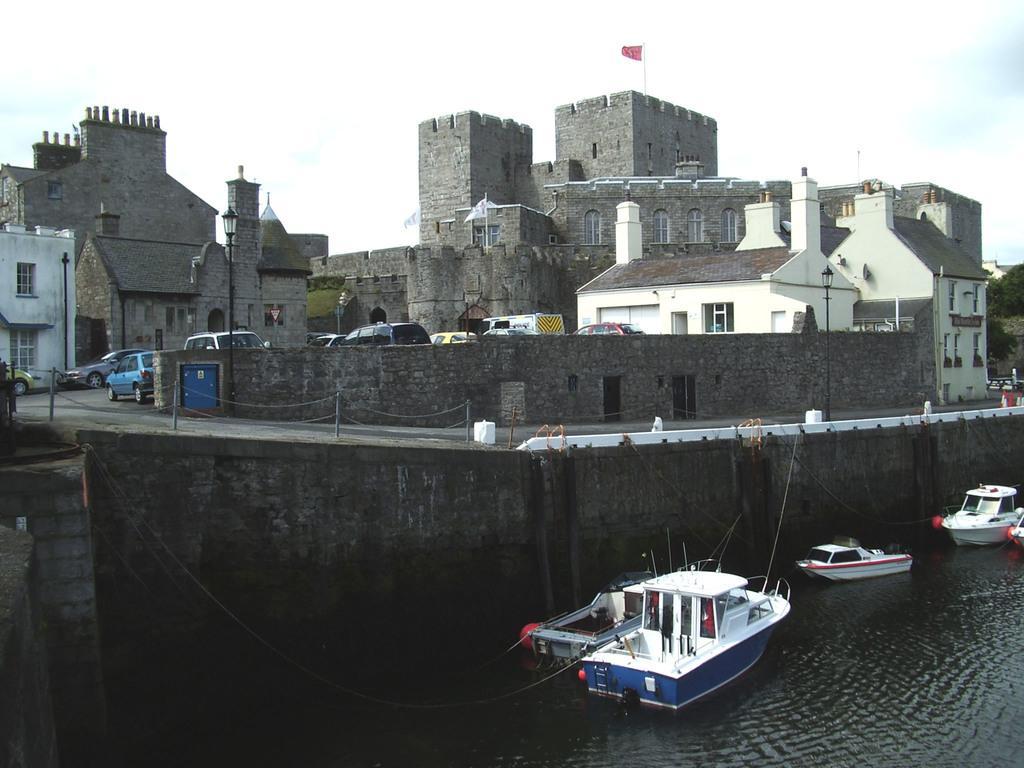In one or two sentences, can you explain what this image depicts? In this image we can see group of boats placed in the water. In the background, we can see group of vehicles parked on the road, a group of buildings, pole, a flag on a building and the sky. 